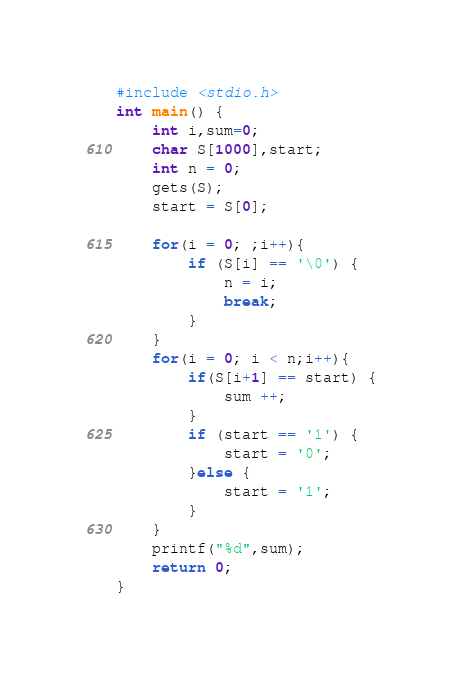Convert code to text. <code><loc_0><loc_0><loc_500><loc_500><_C_>#include <stdio.h>
int main() {
	int i,sum=0;
	char S[1000],start;
	int n = 0;
	gets(S);
	start = S[0];

	for(i = 0; ;i++){
		if (S[i] == '\0') {
			n = i;
			break;
		}
	}
	for(i = 0; i < n;i++){
		if(S[i+1] == start) {
			sum ++;
		}
		if (start == '1') {
			start = '0';
		}else {
			start = '1';
		}
	}
	printf("%d",sum);
	return 0;
}</code> 